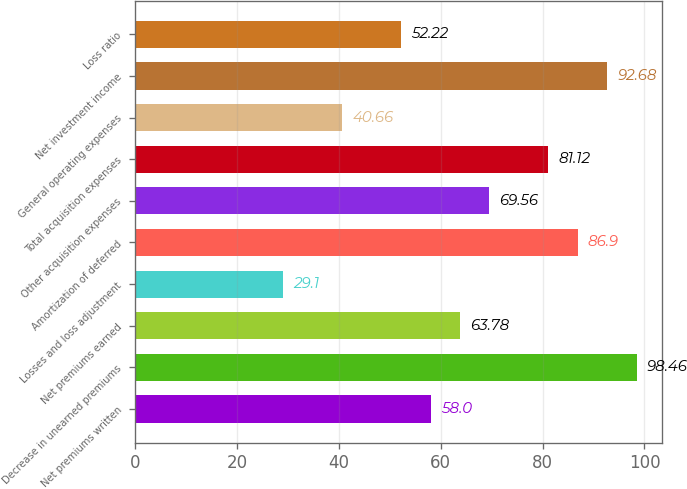Convert chart. <chart><loc_0><loc_0><loc_500><loc_500><bar_chart><fcel>Net premiums written<fcel>Decrease in unearned premiums<fcel>Net premiums earned<fcel>Losses and loss adjustment<fcel>Amortization of deferred<fcel>Other acquisition expenses<fcel>Total acquisition expenses<fcel>General operating expenses<fcel>Net investment income<fcel>Loss ratio<nl><fcel>58<fcel>98.46<fcel>63.78<fcel>29.1<fcel>86.9<fcel>69.56<fcel>81.12<fcel>40.66<fcel>92.68<fcel>52.22<nl></chart> 